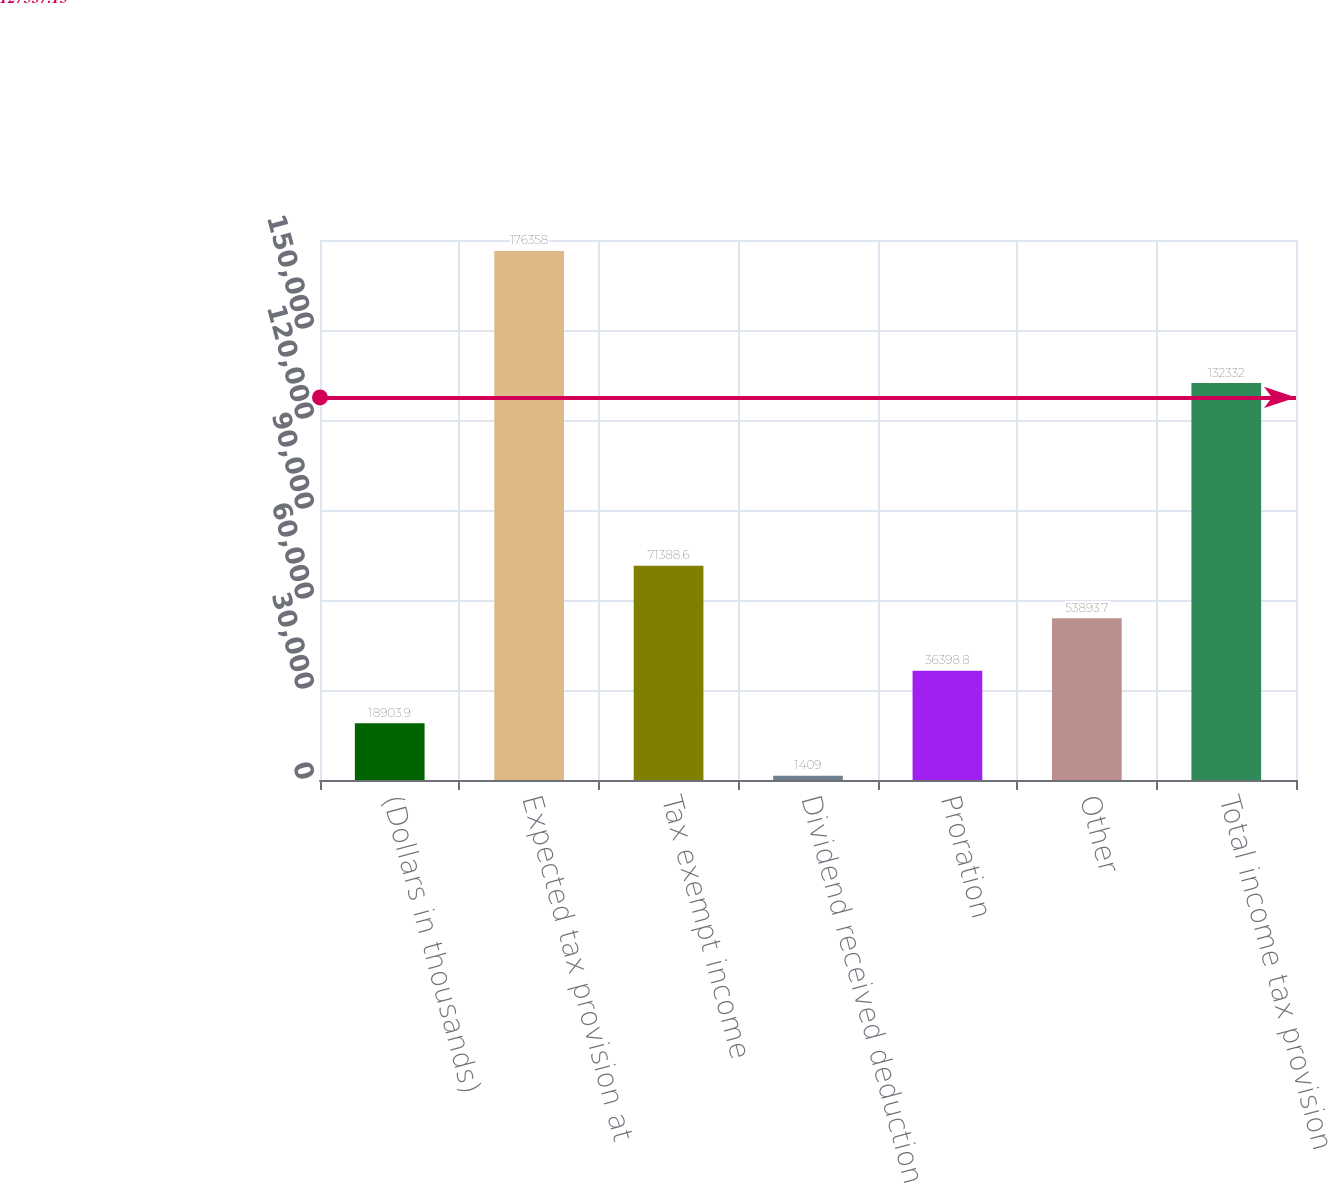Convert chart. <chart><loc_0><loc_0><loc_500><loc_500><bar_chart><fcel>(Dollars in thousands)<fcel>Expected tax provision at<fcel>Tax exempt income<fcel>Dividend received deduction<fcel>Proration<fcel>Other<fcel>Total income tax provision<nl><fcel>18903.9<fcel>176358<fcel>71388.6<fcel>1409<fcel>36398.8<fcel>53893.7<fcel>132332<nl></chart> 